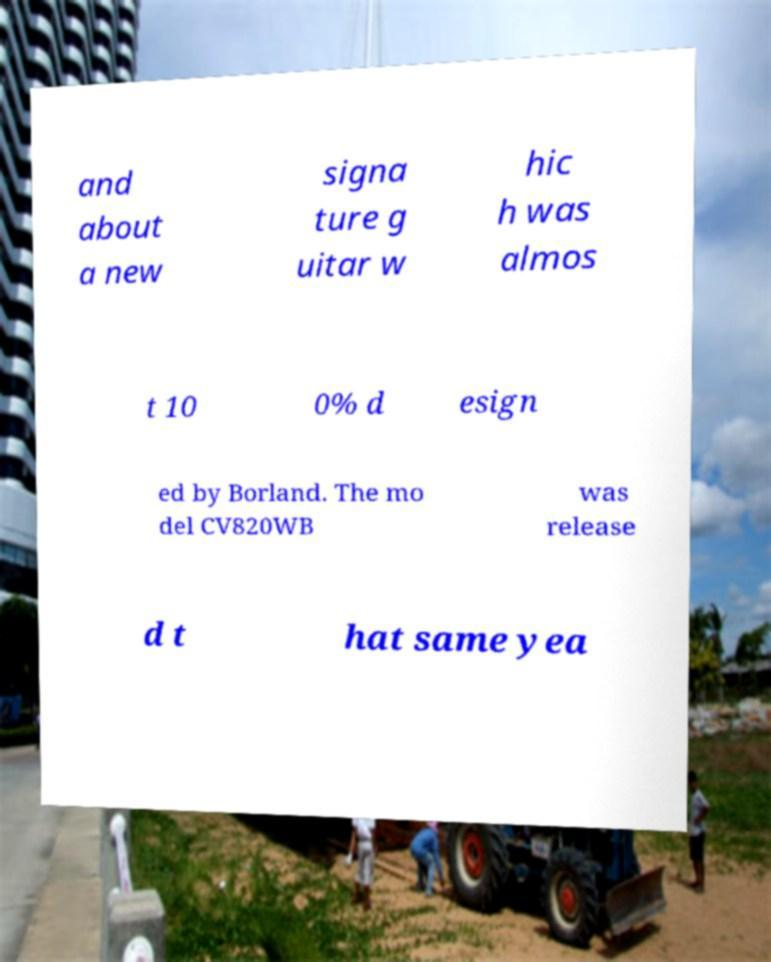There's text embedded in this image that I need extracted. Can you transcribe it verbatim? and about a new signa ture g uitar w hic h was almos t 10 0% d esign ed by Borland. The mo del CV820WB was release d t hat same yea 